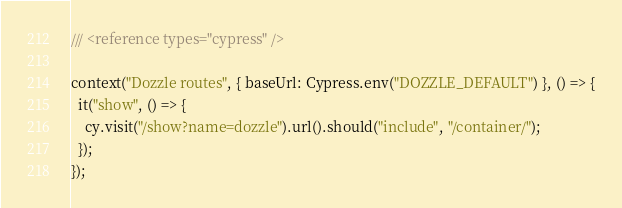<code> <loc_0><loc_0><loc_500><loc_500><_JavaScript_>/// <reference types="cypress" />

context("Dozzle routes", { baseUrl: Cypress.env("DOZZLE_DEFAULT") }, () => {
  it("show", () => {
    cy.visit("/show?name=dozzle").url().should("include", "/container/");
  });
});
</code> 